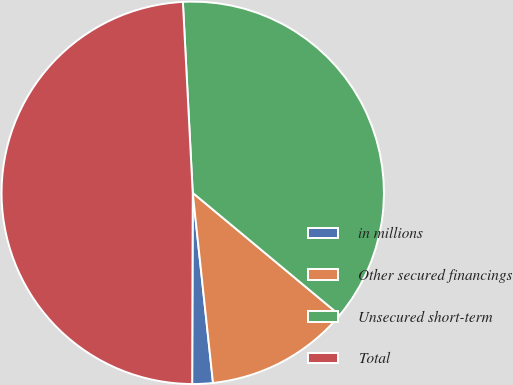<chart> <loc_0><loc_0><loc_500><loc_500><pie_chart><fcel>in millions<fcel>Other secured financings<fcel>Unsecured short-term<fcel>Total<nl><fcel>1.74%<fcel>12.26%<fcel>36.87%<fcel>49.13%<nl></chart> 